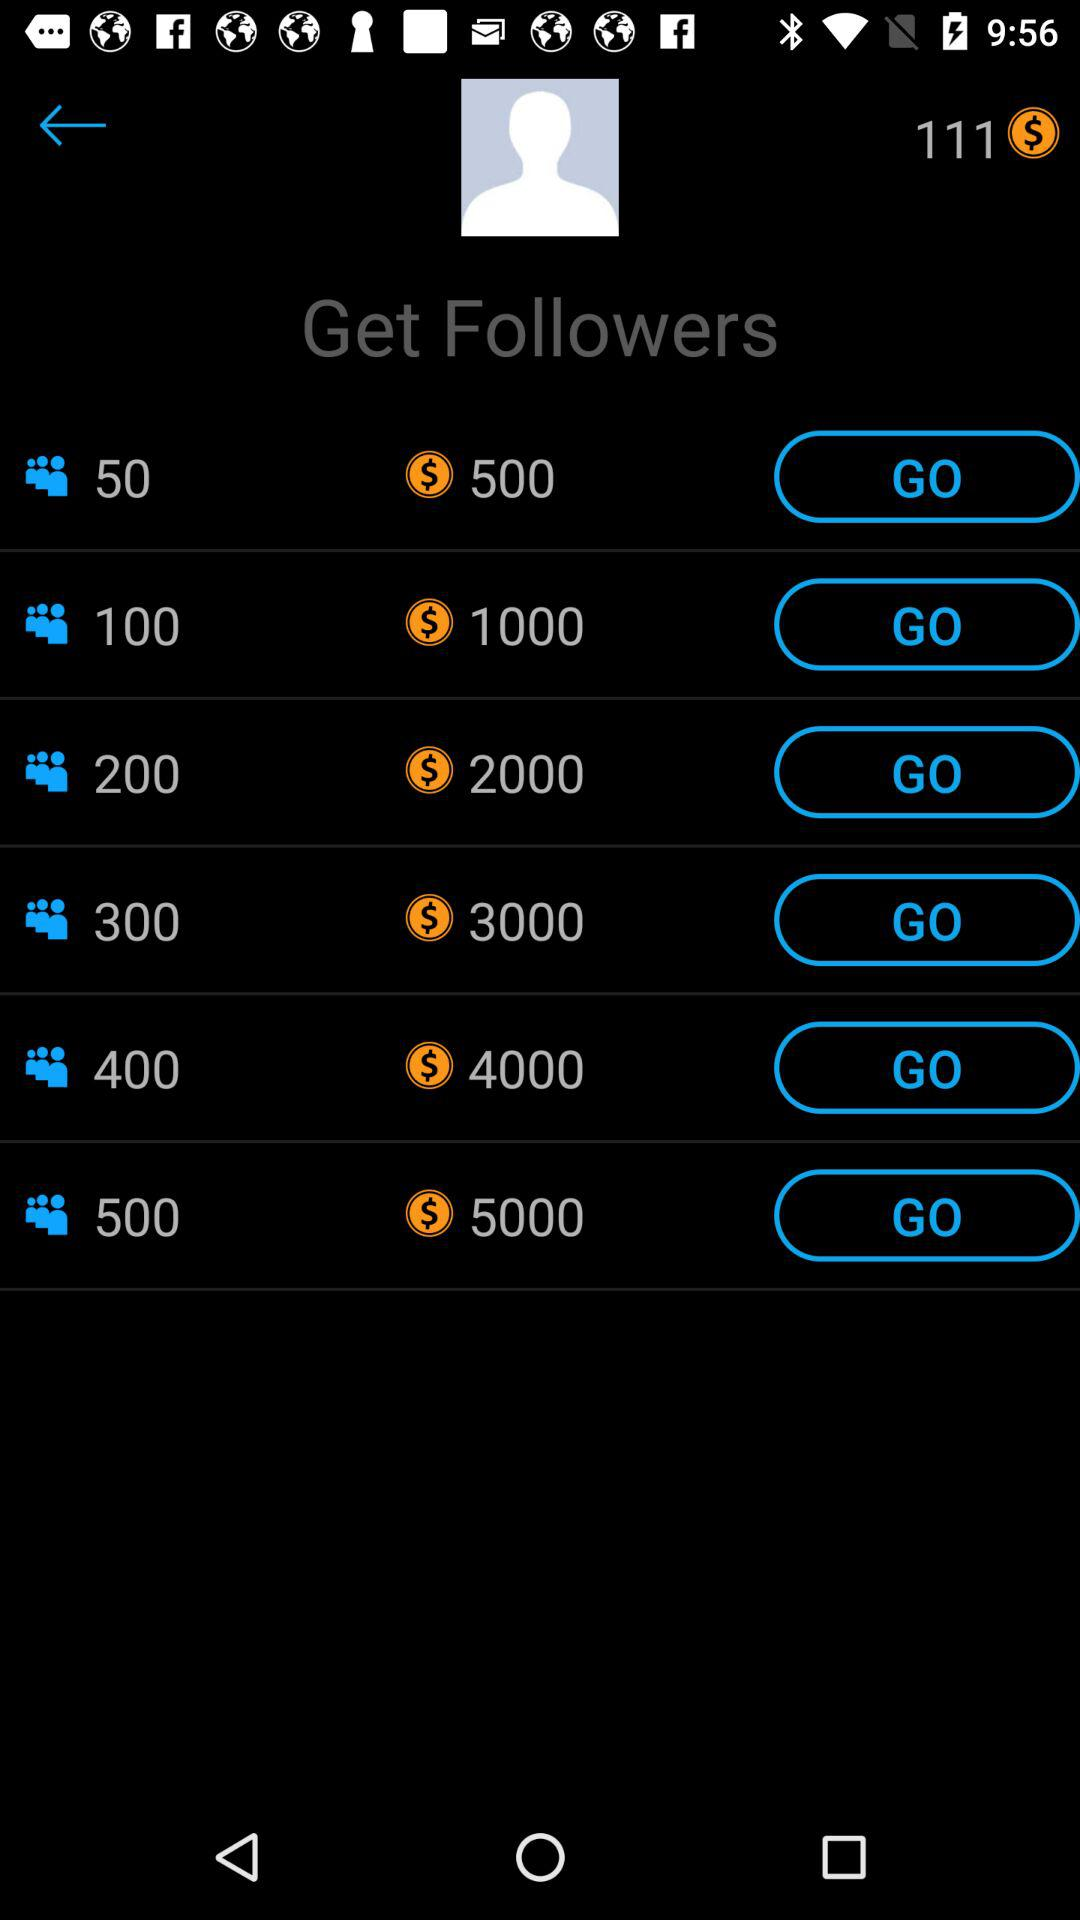How many followers will the user get for $500? The user will get 50 followers for $500. 